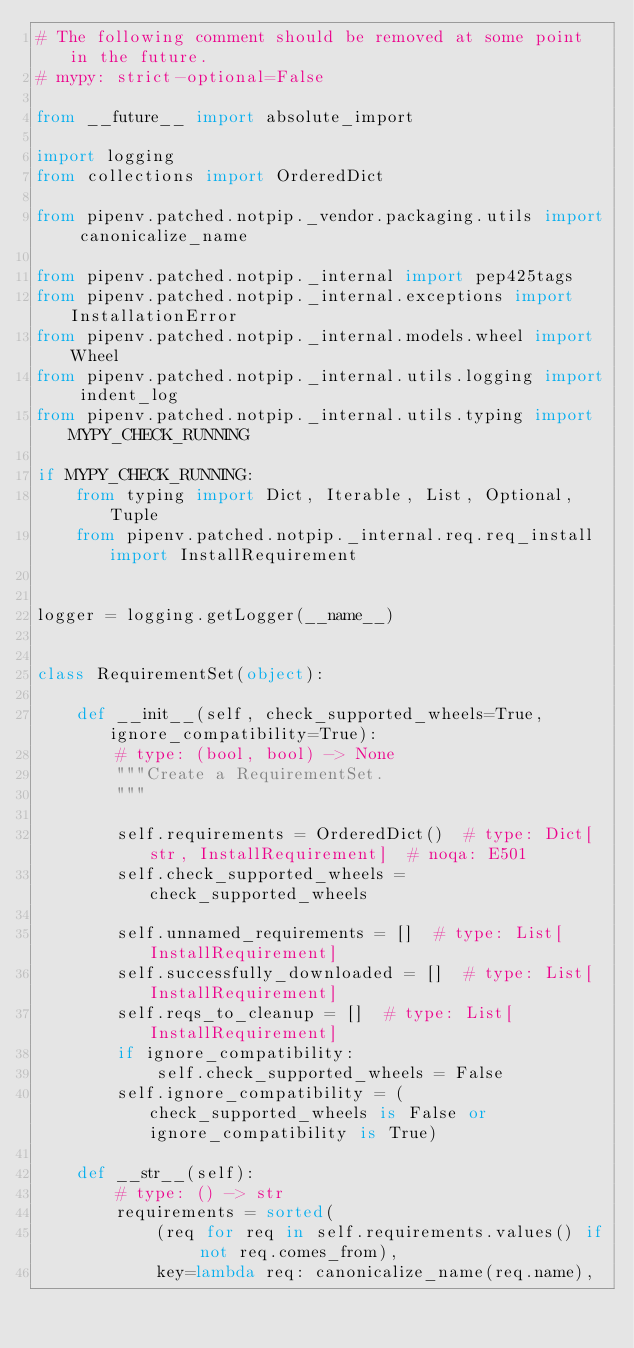Convert code to text. <code><loc_0><loc_0><loc_500><loc_500><_Python_># The following comment should be removed at some point in the future.
# mypy: strict-optional=False

from __future__ import absolute_import

import logging
from collections import OrderedDict

from pipenv.patched.notpip._vendor.packaging.utils import canonicalize_name

from pipenv.patched.notpip._internal import pep425tags
from pipenv.patched.notpip._internal.exceptions import InstallationError
from pipenv.patched.notpip._internal.models.wheel import Wheel
from pipenv.patched.notpip._internal.utils.logging import indent_log
from pipenv.patched.notpip._internal.utils.typing import MYPY_CHECK_RUNNING

if MYPY_CHECK_RUNNING:
    from typing import Dict, Iterable, List, Optional, Tuple
    from pipenv.patched.notpip._internal.req.req_install import InstallRequirement


logger = logging.getLogger(__name__)


class RequirementSet(object):

    def __init__(self, check_supported_wheels=True, ignore_compatibility=True):
        # type: (bool, bool) -> None
        """Create a RequirementSet.
        """

        self.requirements = OrderedDict()  # type: Dict[str, InstallRequirement]  # noqa: E501
        self.check_supported_wheels = check_supported_wheels

        self.unnamed_requirements = []  # type: List[InstallRequirement]
        self.successfully_downloaded = []  # type: List[InstallRequirement]
        self.reqs_to_cleanup = []  # type: List[InstallRequirement]
        if ignore_compatibility:
            self.check_supported_wheels = False
        self.ignore_compatibility = (check_supported_wheels is False or ignore_compatibility is True)

    def __str__(self):
        # type: () -> str
        requirements = sorted(
            (req for req in self.requirements.values() if not req.comes_from),
            key=lambda req: canonicalize_name(req.name),</code> 